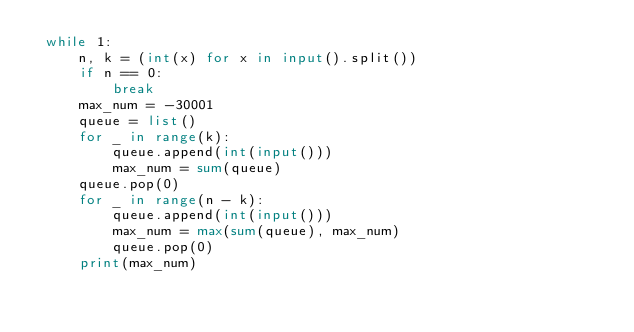Convert code to text. <code><loc_0><loc_0><loc_500><loc_500><_Python_> while 1:                                    
     n, k = (int(x) for x in input().split())
     if n == 0:                              
         break                               
     max_num = -30001                        
     queue = list()                          
     for _ in range(k):                      
         queue.append(int(input()))          
         max_num = sum(queue)                
     queue.pop(0)                            
     for _ in range(n - k):                  
         queue.append(int(input()))          
         max_num = max(sum(queue), max_num)  
         queue.pop(0)                        
     print(max_num)                          </code> 